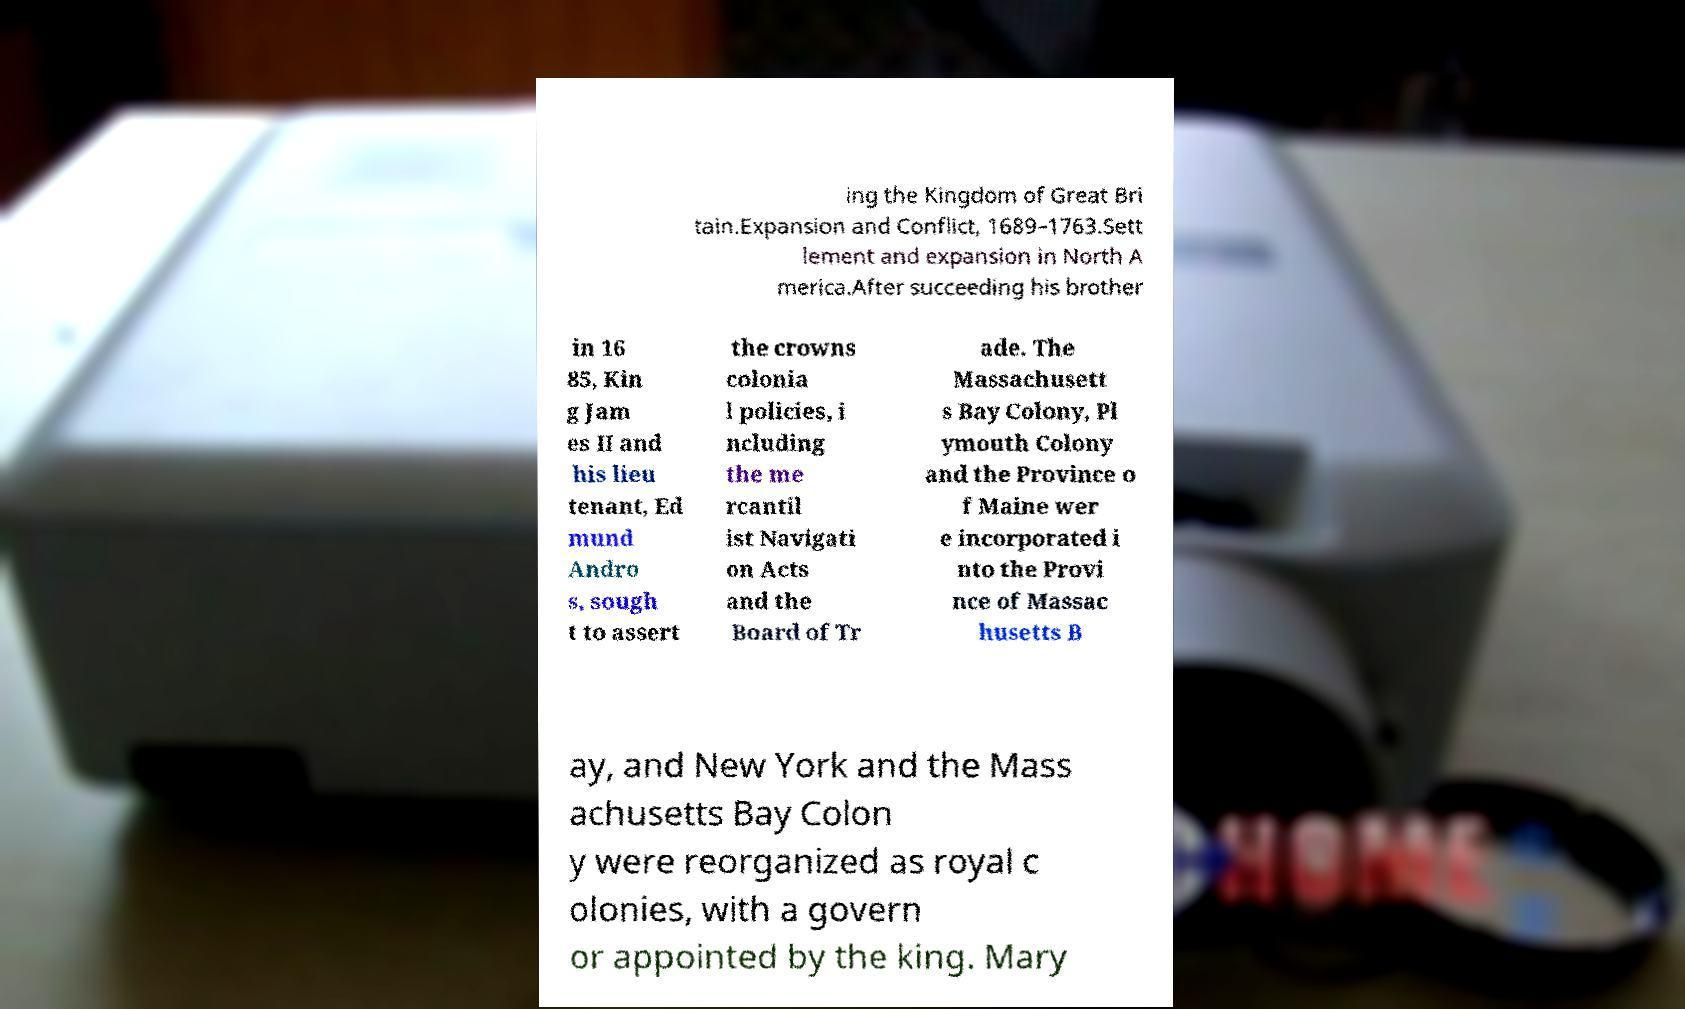Can you read and provide the text displayed in the image?This photo seems to have some interesting text. Can you extract and type it out for me? ing the Kingdom of Great Bri tain.Expansion and Conflict, 1689–1763.Sett lement and expansion in North A merica.After succeeding his brother in 16 85, Kin g Jam es II and his lieu tenant, Ed mund Andro s, sough t to assert the crowns colonia l policies, i ncluding the me rcantil ist Navigati on Acts and the Board of Tr ade. The Massachusett s Bay Colony, Pl ymouth Colony and the Province o f Maine wer e incorporated i nto the Provi nce of Massac husetts B ay, and New York and the Mass achusetts Bay Colon y were reorganized as royal c olonies, with a govern or appointed by the king. Mary 